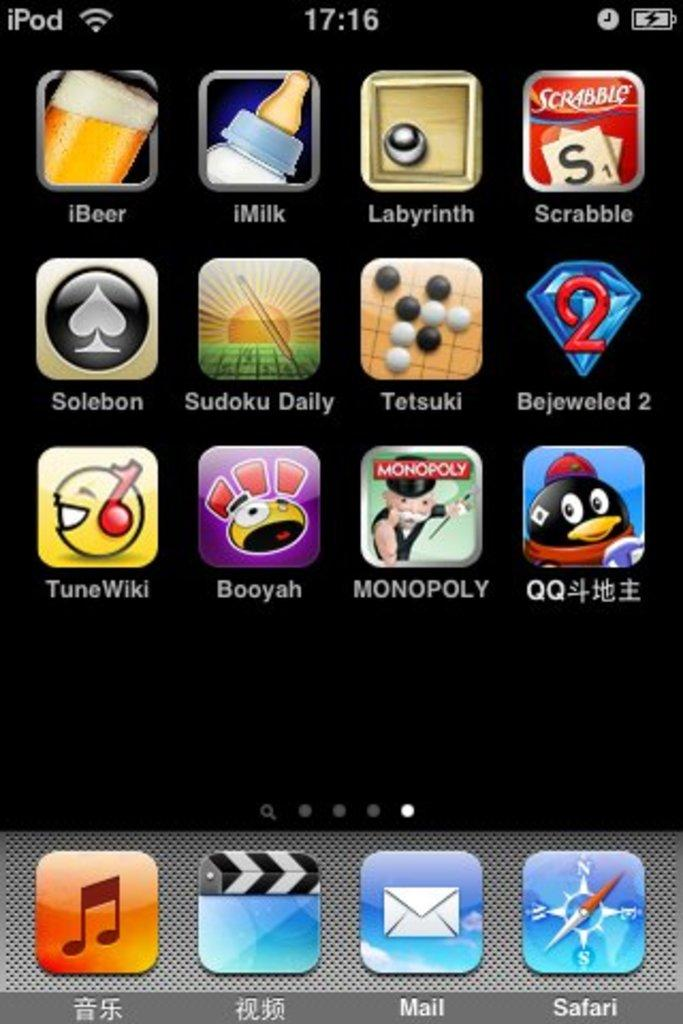<image>
Provide a brief description of the given image. A iPod screen shows apps like Bejeweled Blitz 2 and  Scrabble. 